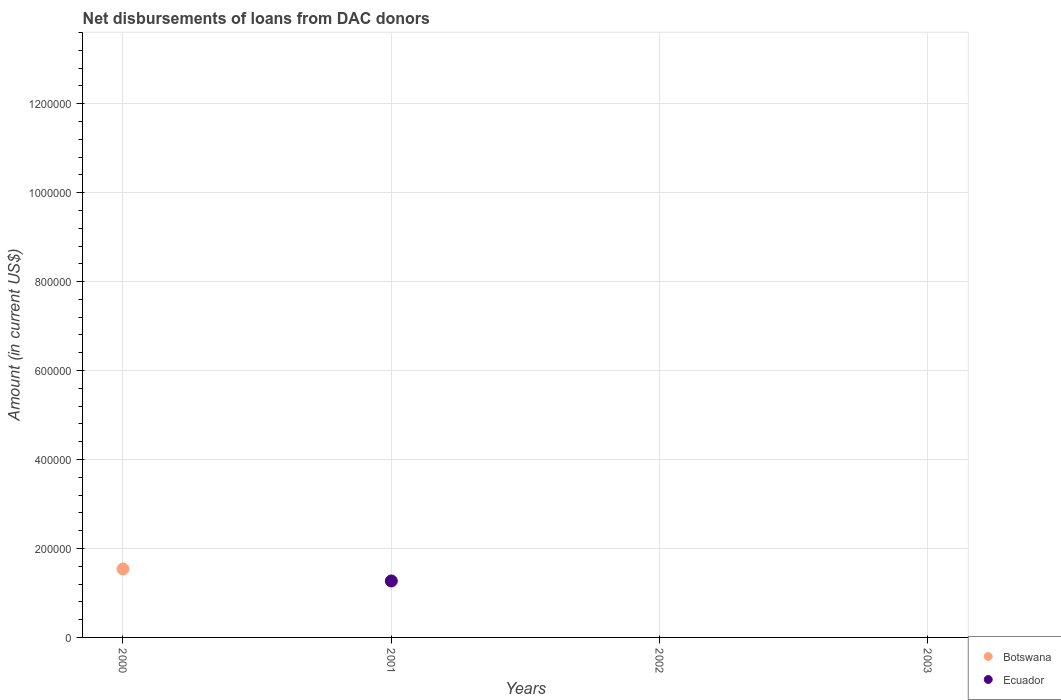How many different coloured dotlines are there?
Provide a succinct answer. 2. Is the number of dotlines equal to the number of legend labels?
Your response must be concise. No. Across all years, what is the maximum amount of loans disbursed in Botswana?
Ensure brevity in your answer.  1.54e+05. In which year was the amount of loans disbursed in Ecuador maximum?
Provide a short and direct response. 2001. What is the total amount of loans disbursed in Botswana in the graph?
Ensure brevity in your answer.  1.54e+05. What is the average amount of loans disbursed in Ecuador per year?
Make the answer very short. 3.18e+04. What is the difference between the highest and the lowest amount of loans disbursed in Botswana?
Provide a succinct answer. 1.54e+05. In how many years, is the amount of loans disbursed in Botswana greater than the average amount of loans disbursed in Botswana taken over all years?
Ensure brevity in your answer.  1. Does the amount of loans disbursed in Botswana monotonically increase over the years?
Provide a succinct answer. No. How many years are there in the graph?
Make the answer very short. 4. What is the difference between two consecutive major ticks on the Y-axis?
Ensure brevity in your answer.  2.00e+05. Are the values on the major ticks of Y-axis written in scientific E-notation?
Your answer should be very brief. No. Where does the legend appear in the graph?
Your response must be concise. Bottom right. How many legend labels are there?
Give a very brief answer. 2. What is the title of the graph?
Provide a succinct answer. Net disbursements of loans from DAC donors. Does "Palau" appear as one of the legend labels in the graph?
Keep it short and to the point. No. What is the Amount (in current US$) of Botswana in 2000?
Your response must be concise. 1.54e+05. What is the Amount (in current US$) in Ecuador in 2000?
Your response must be concise. 0. What is the Amount (in current US$) in Ecuador in 2001?
Your answer should be compact. 1.27e+05. What is the Amount (in current US$) of Botswana in 2002?
Provide a succinct answer. 0. What is the Amount (in current US$) in Ecuador in 2002?
Make the answer very short. 0. Across all years, what is the maximum Amount (in current US$) in Botswana?
Provide a short and direct response. 1.54e+05. Across all years, what is the maximum Amount (in current US$) in Ecuador?
Your response must be concise. 1.27e+05. Across all years, what is the minimum Amount (in current US$) in Ecuador?
Provide a succinct answer. 0. What is the total Amount (in current US$) in Botswana in the graph?
Your response must be concise. 1.54e+05. What is the total Amount (in current US$) of Ecuador in the graph?
Your response must be concise. 1.27e+05. What is the difference between the Amount (in current US$) of Botswana in 2000 and the Amount (in current US$) of Ecuador in 2001?
Make the answer very short. 2.70e+04. What is the average Amount (in current US$) of Botswana per year?
Make the answer very short. 3.85e+04. What is the average Amount (in current US$) in Ecuador per year?
Your answer should be compact. 3.18e+04. What is the difference between the highest and the lowest Amount (in current US$) in Botswana?
Give a very brief answer. 1.54e+05. What is the difference between the highest and the lowest Amount (in current US$) of Ecuador?
Keep it short and to the point. 1.27e+05. 